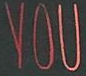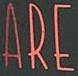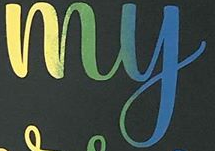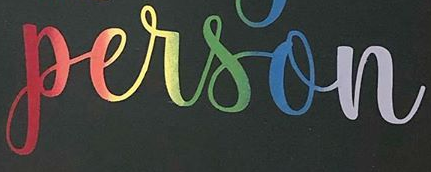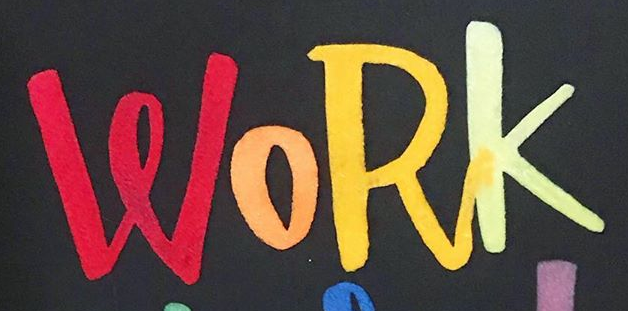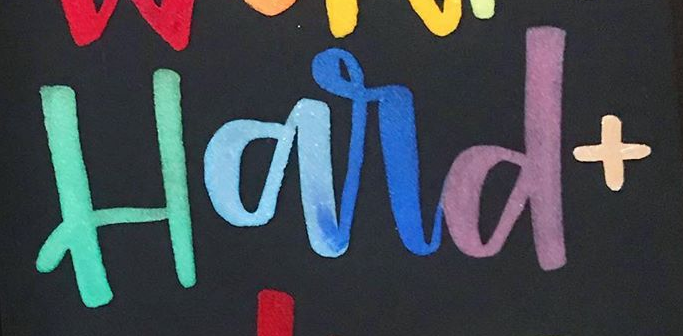Read the text from these images in sequence, separated by a semicolon. YOU; ARE; my; person; WORK; Hard+ 